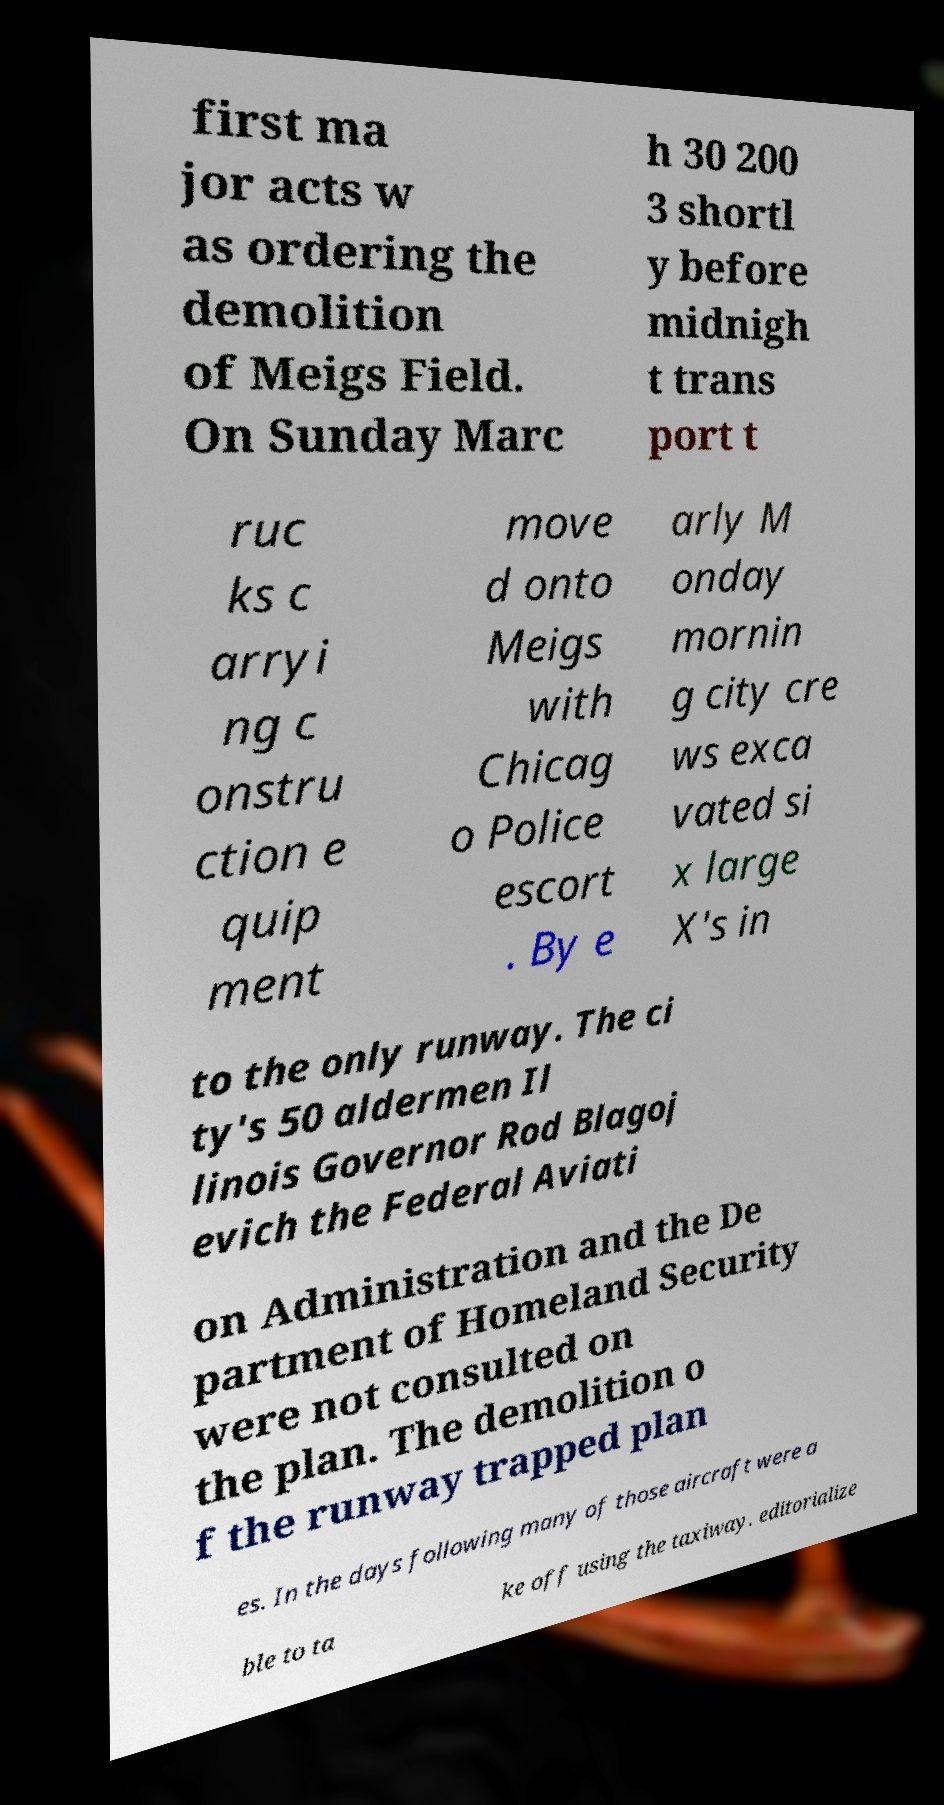Please read and relay the text visible in this image. What does it say? first ma jor acts w as ordering the demolition of Meigs Field. On Sunday Marc h 30 200 3 shortl y before midnigh t trans port t ruc ks c arryi ng c onstru ction e quip ment move d onto Meigs with Chicag o Police escort . By e arly M onday mornin g city cre ws exca vated si x large X's in to the only runway. The ci ty's 50 aldermen Il linois Governor Rod Blagoj evich the Federal Aviati on Administration and the De partment of Homeland Security were not consulted on the plan. The demolition o f the runway trapped plan es. In the days following many of those aircraft were a ble to ta ke off using the taxiway. editorialize 